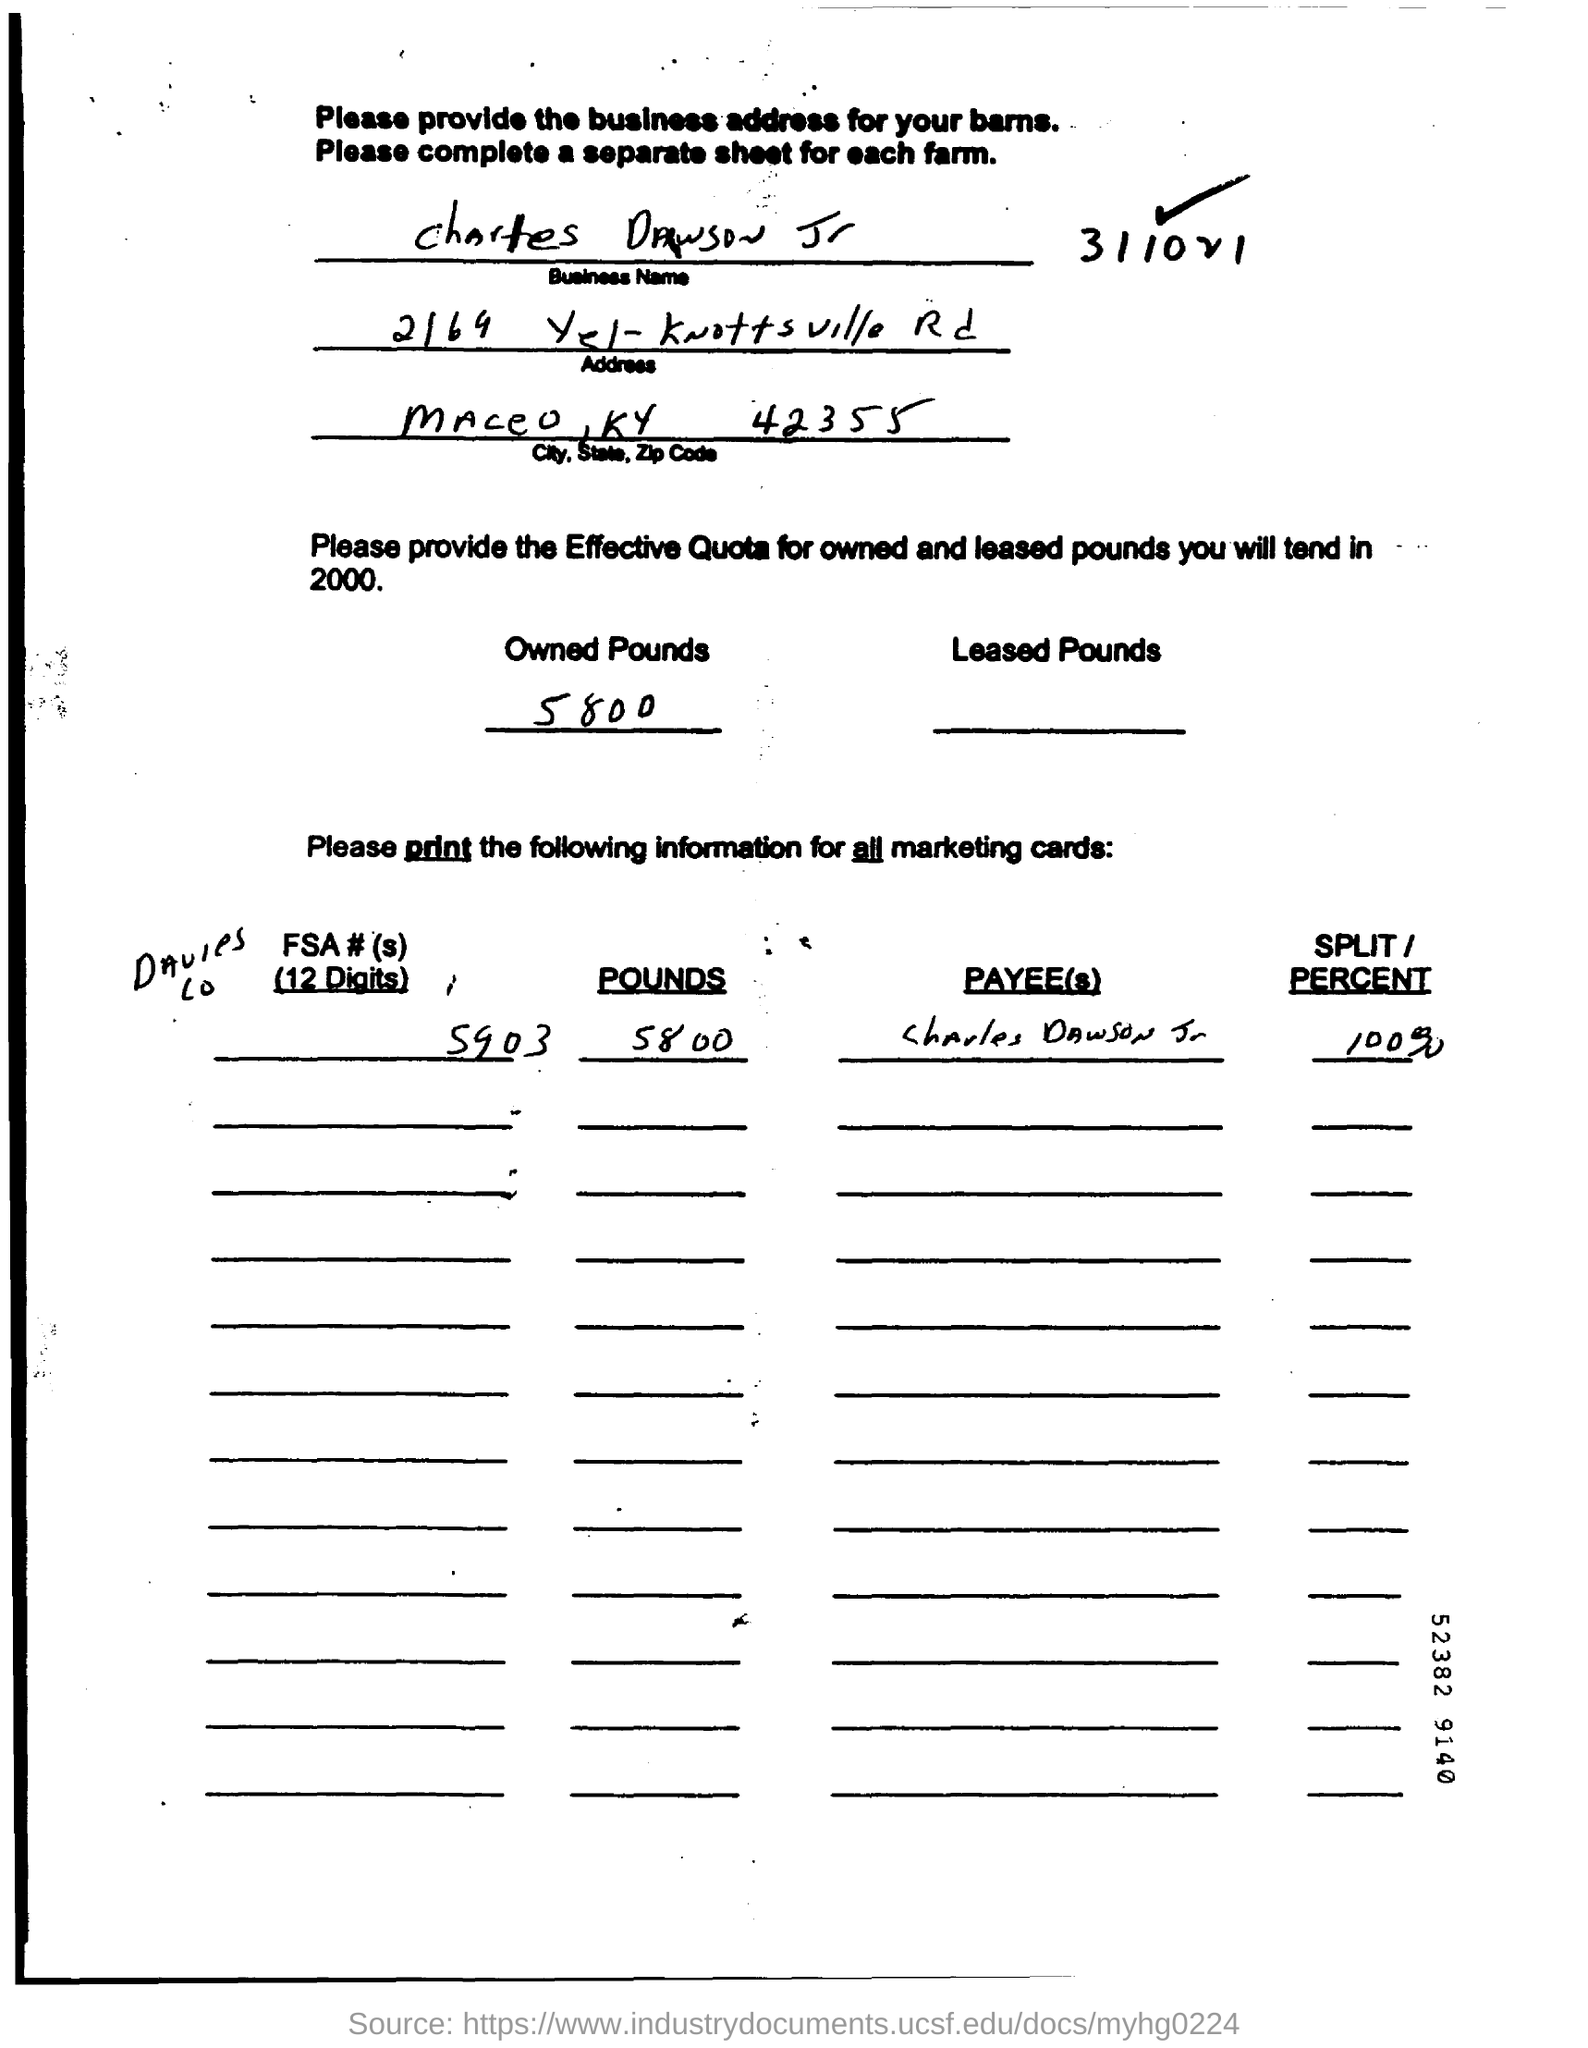List a handful of essential elements in this visual. The effective quota for owned pounds in 2000 was 5,800. The business name of the person named in the document is Charles Dawson Jr. 